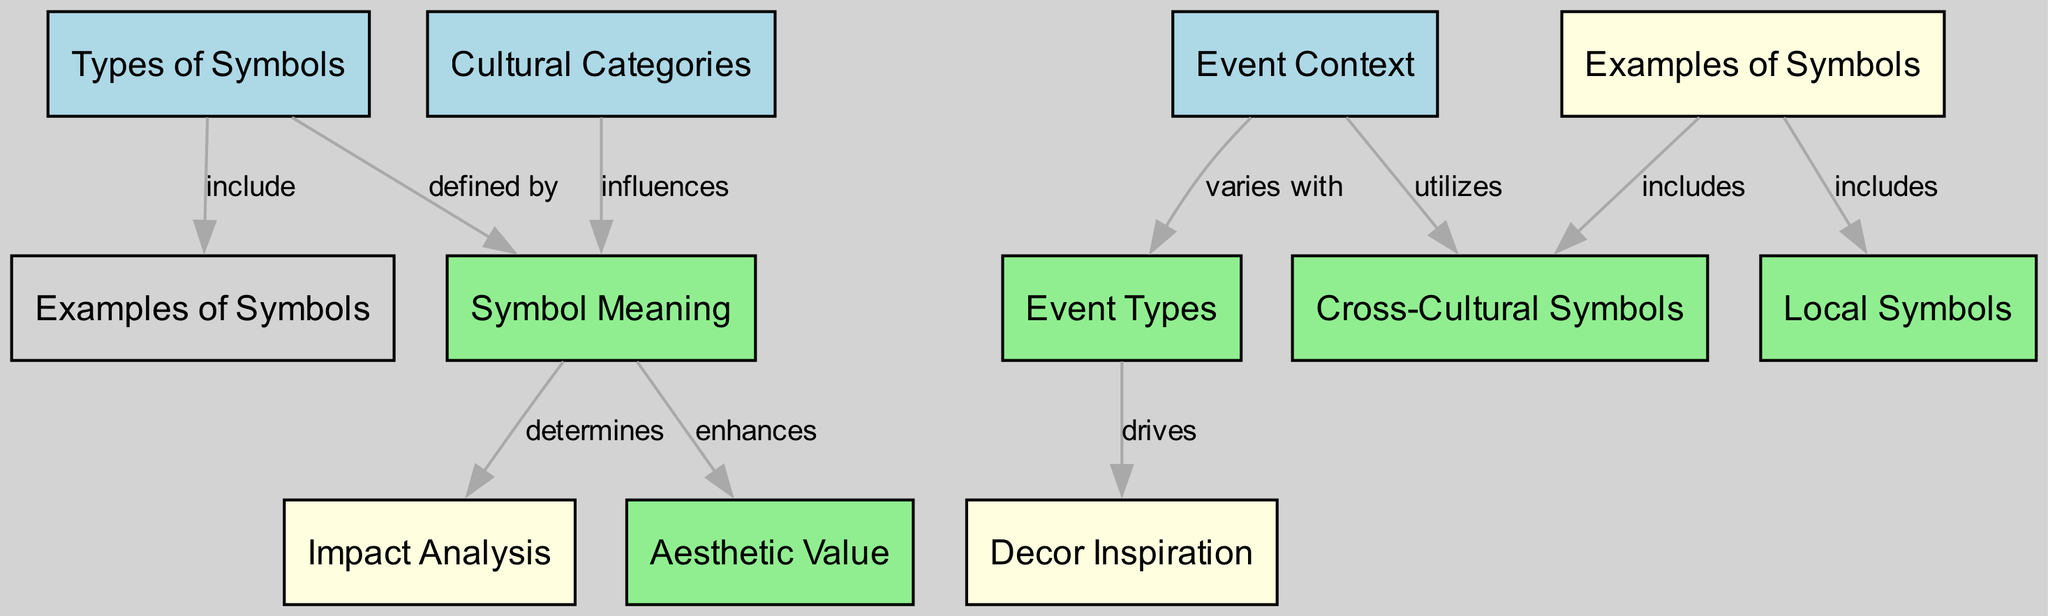What are the three types of symbols included in the diagram? The diagram shows three types of symbols, which can be found in the node labeled "Types of Symbols." These are the categories that the symbols fall under, which are visually represented in the respective node.
Answer: Types of Symbols How many edges are there in the diagram? By counting the edges that connect the nodes in the diagram, we find a total of 10 connections. This is done by identifying each label on the edges and tallying them.
Answer: 10 What does "Cultural Categories" influence? According to the diagram, "Cultural Categories" influences the meaning of symbols, as indicated by the directed edge that originates from "Cultural Categories" and points to "Symbol Meaning."
Answer: Symbol Meaning Which node is driven by "Event Types"? The diagram indicates that "Decor Inspiration" is driven by "Event Types," as shown by the direct edge from "Event Types" leading to "Decor Inspiration." This establishes a cause-effect relationship.
Answer: Decor Inspiration What are the examples of symbols categorized under "Symbol Examples"? Looking at the node "Examples of Symbols," it provides a classification that includes local symbols and cross-cultural symbols, which are specifically listed as examples in the diagram.
Answer: Local Symbols, Cross-Cultural Symbols Which types of symbols are defined by their meanings? The "Symbol Meaning" node is defined by the "Types of Symbols" node, where the relationship is clearly indicated by the edge connecting them, illustrating that the symbols have specific meanings associated with them.
Answer: Types of Symbols What impacts the aesthetic value according to the diagram? The diagram reveals that "Symbol Meaning" enhances "Aesthetic Value," indicated by the directional edge that highlights how the meaning contributes to the overall aesthetic appeal in event decor.
Answer: Symbol Meaning Which cultural symbols are utilized in "Event Context"? The "Cross-Cultural Symbols" node is utilized in the context of events, as represented by the directed edge that points from "Event Context" to "Cross-Cultural Symbols." This shows the inclusion of broader cultural symbols in event design.
Answer: Cross-Cultural Symbols How does "Symbol Examples" relate to "Local Symbols"? The relationship is established through the edge connecting "Symbol Examples" with "Local Symbols," indicating that local symbols are part of the examples provided under that node.
Answer: Local Symbols 